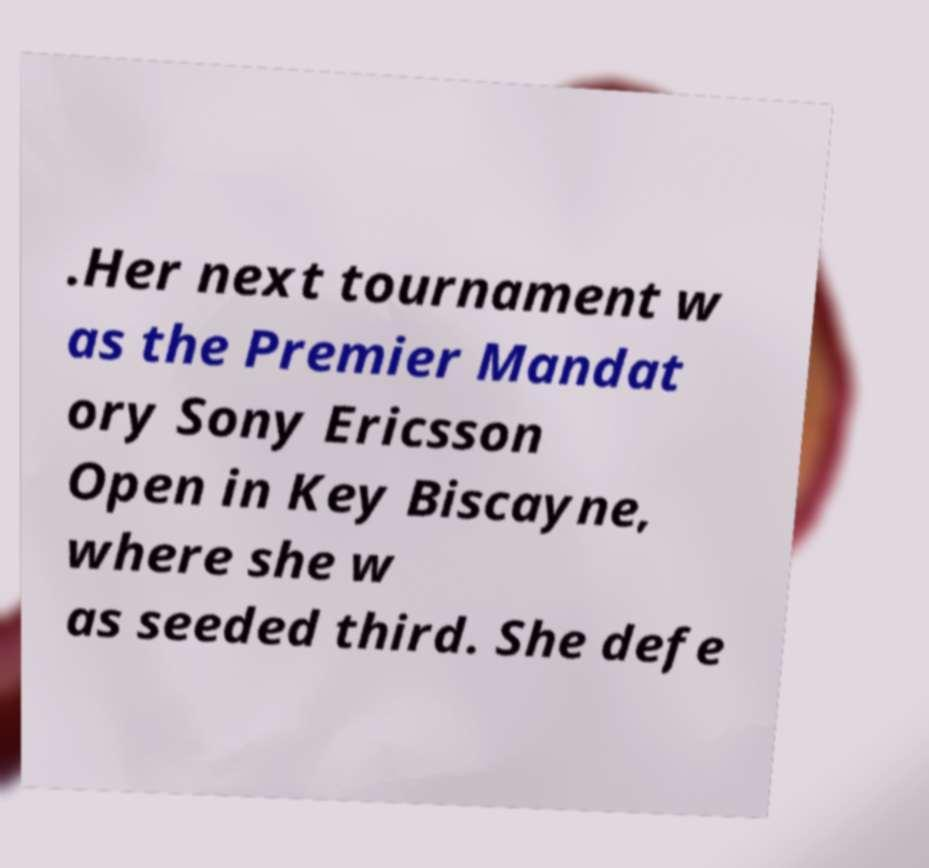For documentation purposes, I need the text within this image transcribed. Could you provide that? .Her next tournament w as the Premier Mandat ory Sony Ericsson Open in Key Biscayne, where she w as seeded third. She defe 